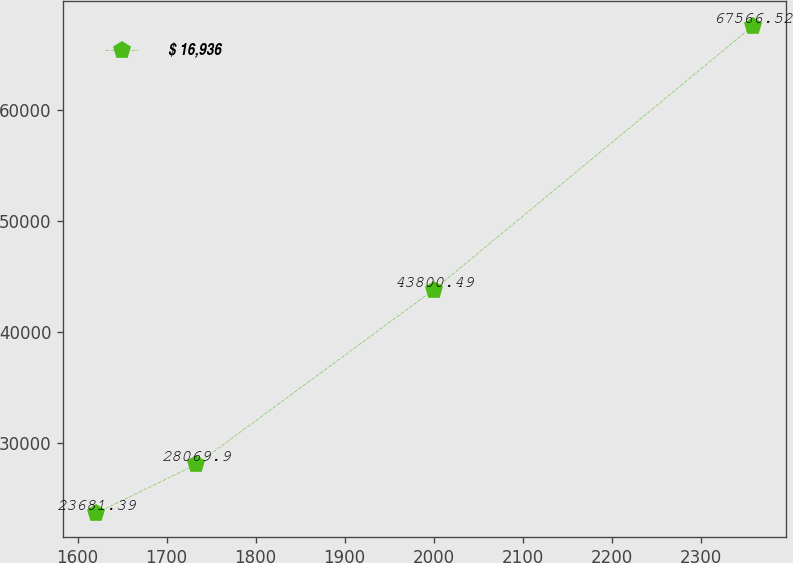Convert chart. <chart><loc_0><loc_0><loc_500><loc_500><line_chart><ecel><fcel>$ 16,936<nl><fcel>1620.89<fcel>23681.4<nl><fcel>1733.57<fcel>28069.9<nl><fcel>2000.27<fcel>43800.5<nl><fcel>2359.09<fcel>67566.5<nl></chart> 